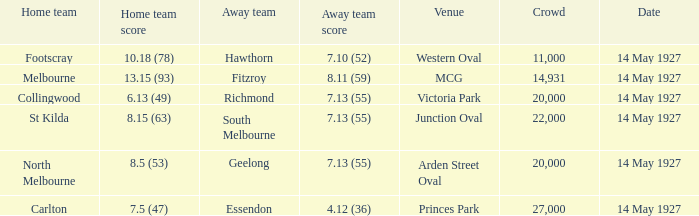Which venue hosted a home team with a score of 13.15 (93)? MCG. 